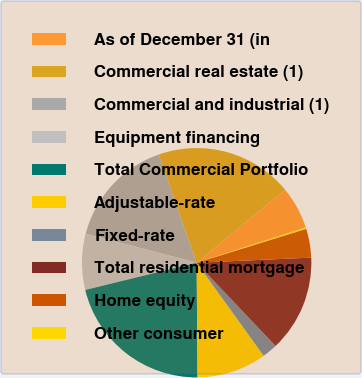Convert chart to OTSL. <chart><loc_0><loc_0><loc_500><loc_500><pie_chart><fcel>As of December 31 (in<fcel>Commercial real estate (1)<fcel>Commercial and industrial (1)<fcel>Equipment financing<fcel>Total Commercial Portfolio<fcel>Adjustable-rate<fcel>Fixed-rate<fcel>Total residential mortgage<fcel>Home equity<fcel>Other consumer<nl><fcel>5.98%<fcel>19.39%<fcel>15.56%<fcel>7.89%<fcel>21.31%<fcel>9.81%<fcel>2.14%<fcel>13.64%<fcel>4.06%<fcel>0.23%<nl></chart> 